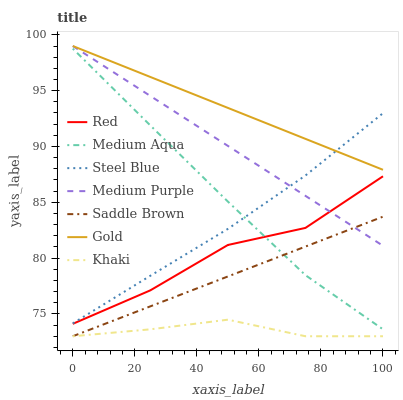Does Khaki have the minimum area under the curve?
Answer yes or no. Yes. Does Gold have the maximum area under the curve?
Answer yes or no. Yes. Does Steel Blue have the minimum area under the curve?
Answer yes or no. No. Does Steel Blue have the maximum area under the curve?
Answer yes or no. No. Is Medium Purple the smoothest?
Answer yes or no. Yes. Is Red the roughest?
Answer yes or no. Yes. Is Gold the smoothest?
Answer yes or no. No. Is Gold the roughest?
Answer yes or no. No. Does Khaki have the lowest value?
Answer yes or no. Yes. Does Steel Blue have the lowest value?
Answer yes or no. No. Does Medium Purple have the highest value?
Answer yes or no. Yes. Does Steel Blue have the highest value?
Answer yes or no. No. Is Red less than Steel Blue?
Answer yes or no. Yes. Is Steel Blue greater than Saddle Brown?
Answer yes or no. Yes. Does Medium Aqua intersect Steel Blue?
Answer yes or no. Yes. Is Medium Aqua less than Steel Blue?
Answer yes or no. No. Is Medium Aqua greater than Steel Blue?
Answer yes or no. No. Does Red intersect Steel Blue?
Answer yes or no. No. 